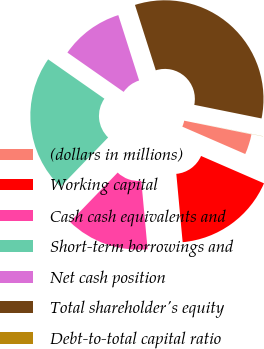Convert chart. <chart><loc_0><loc_0><loc_500><loc_500><pie_chart><fcel>(dollars in millions)<fcel>Working capital<fcel>Cash cash equivalents and<fcel>Short-term borrowings and<fcel>Net cash position<fcel>Total shareholder's equity<fcel>Debt-to-total capital ratio<nl><fcel>3.33%<fcel>17.0%<fcel>13.69%<fcel>22.49%<fcel>10.38%<fcel>33.08%<fcel>0.02%<nl></chart> 